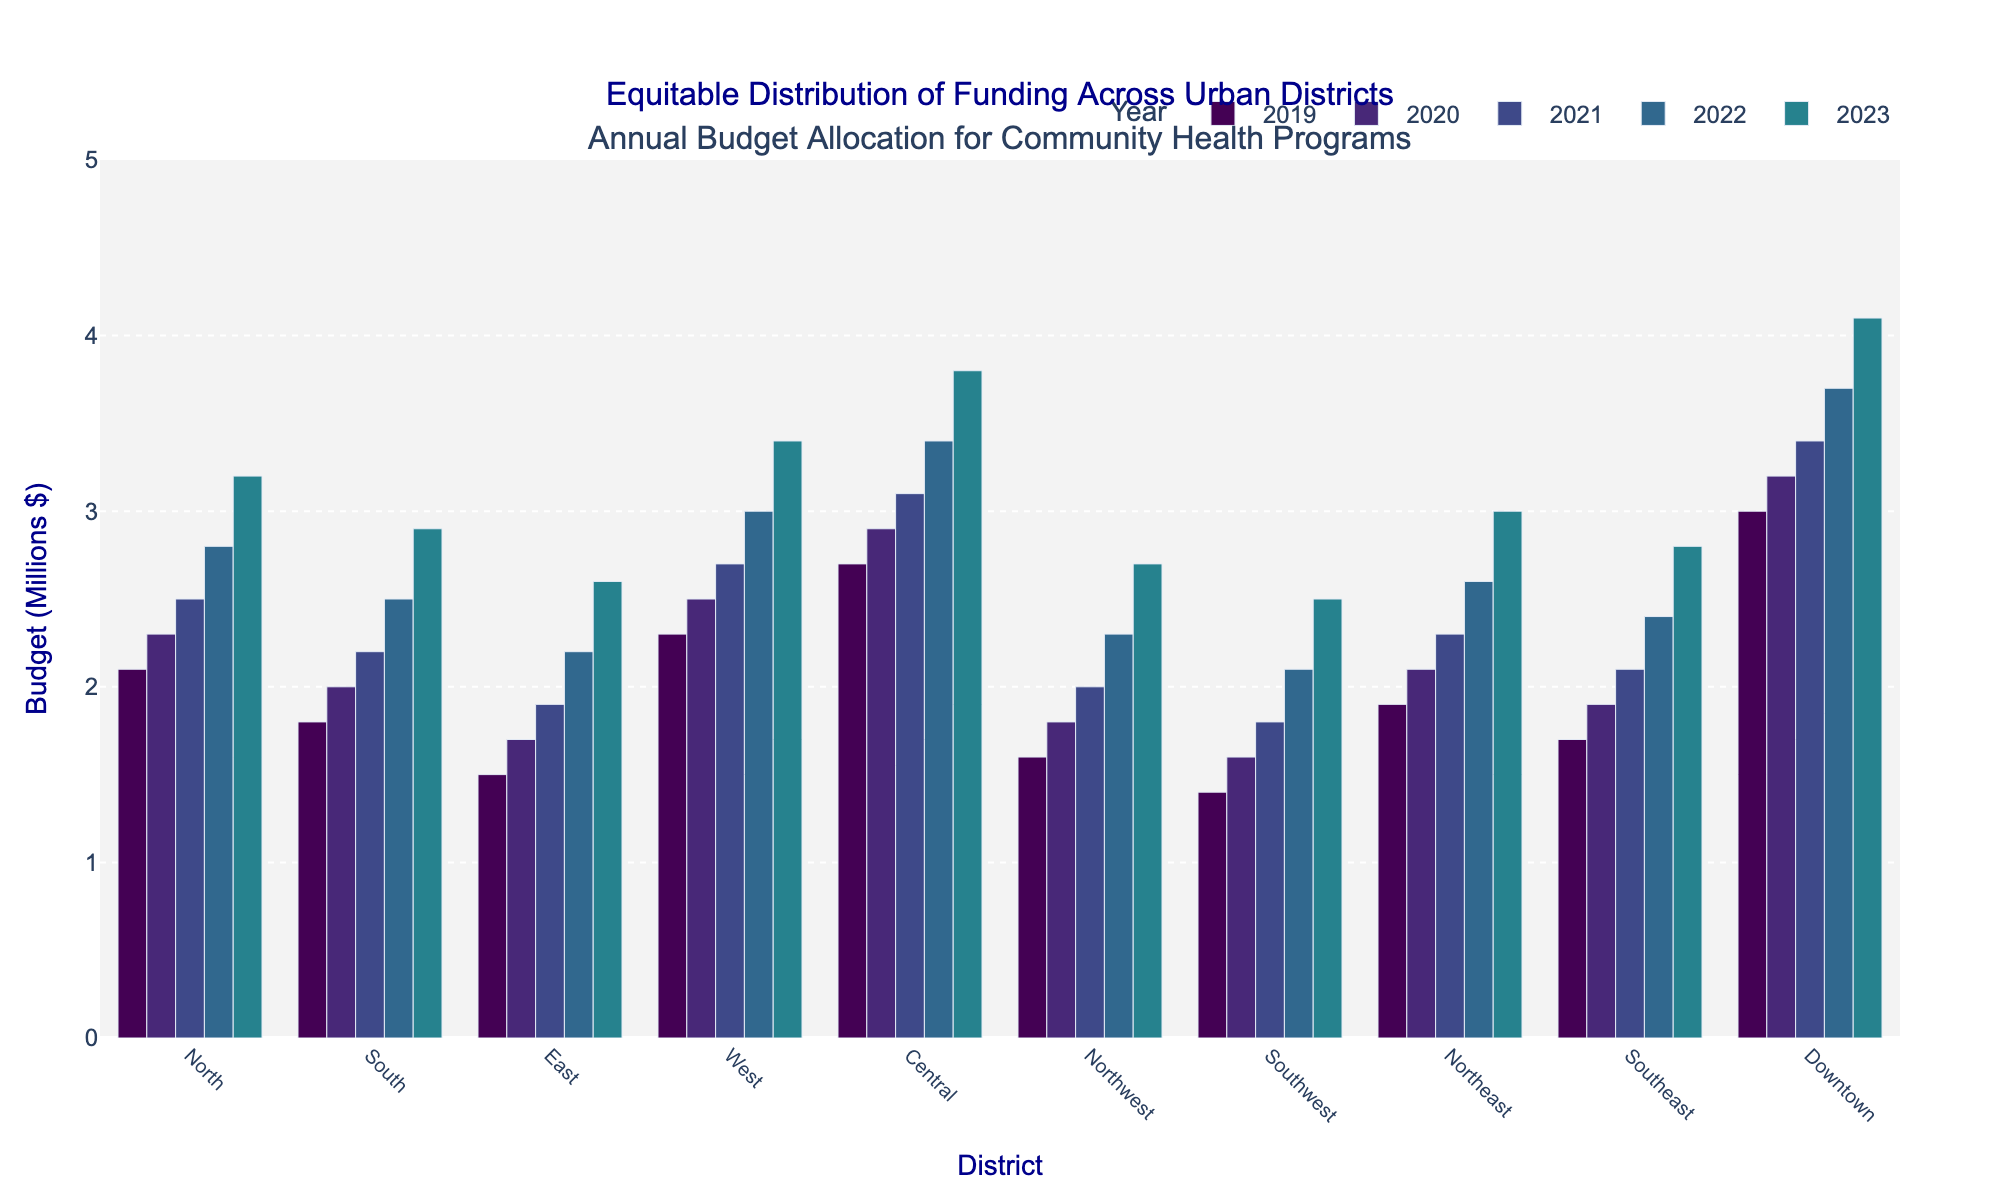What is the total budget allocation for the Central district over the past 5 years? Sum up the budget allocations for each year for the Central district: 2.7 (2019) + 2.9 (2020) + 3.1 (2021) + 3.4 (2022) + 3.8 (2023) = 15.9
Answer: 15.9 Which district received the highest budget allocation in 2023? Refer to the bars for 2023, the Downtown district has the highest budget allocation of 4.1
Answer: Downtown Compare the budget allocation for the West district between 2019 and 2023. How much has it increased? The budget in 2019 for West was 2.3 and in 2023 it was 3.4. The increase is 3.4 - 2.3 = 1.1
Answer: 1.1 Which district had the least amount of funding in 2020? By comparing the bars for 2020, the Southwest district had the least funding with 1.6
Answer: Southwest Which two districts had the closest budget allocation in 2022, and what were their values? Look at the bars for 2022, North and Southeast have very close allocations, with North at 2.8 and Southeast at 2.4
Answer: North: 2.8, Southeast: 2.4 What is the average annual budget allocation for the Northeast district over the past 5 years? Sum the values for the Northeast district from 2019 to 2023: 1.9 + 2.1 + 2.3 + 2.6 + 3.0 = 11.9. Then divide by 5: 11.9 / 5 = 2.38
Answer: 2.38 Which year saw the highest average budget allocation across all districts? Calculate the average for each year. For example, 2019's average is (2.1 + 1.8 + 1.5 + 2.3 + 2.7 + 1.6 + 1.4 + 1.9 + 1.7 + 3.0) / 10 = 2.0. Repeat for each year and compare the results; 2023 has the highest with an average of 3.2
Answer: 2023 How much more funding did the Downtown district receive compared to the Southwest district in 2021? Downtown received 3.4 and Southwest received 1.8 in 2021. The difference is 3.4 - 1.8 = 1.6
Answer: 1.6 Which district showed the most significant increase in budget allocation from 2019 to 2023? Calculate the increase for each district: for example, for North, it's 3.2 - 2.1 = 1.1. Central has the most significant increase at 3.8 - 2.7 = 1.1. Repeat for each and identify the district with the highest increase. It is Central
Answer: Central Identify the district with the most consistent year-on-year budget allocation growth and its yearly increments. Check the increments for each district. Downtown has consistent increments: 3.0, 3.2, 3.4, 3.7, 4.1. Each increment is around 0.2-0.3, making it the most consistent
Answer: Downtown 